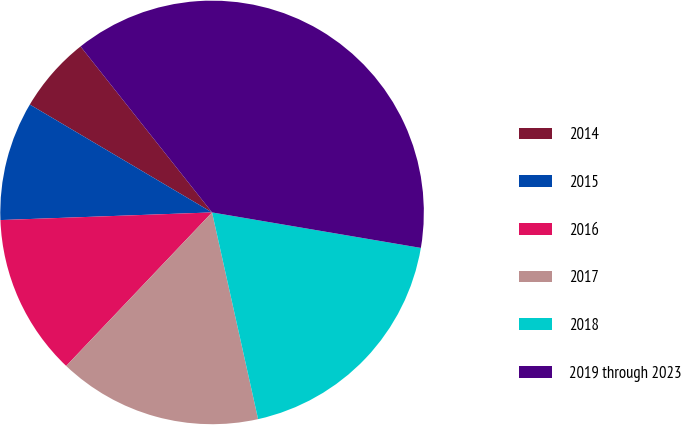Convert chart to OTSL. <chart><loc_0><loc_0><loc_500><loc_500><pie_chart><fcel>2014<fcel>2015<fcel>2016<fcel>2017<fcel>2018<fcel>2019 through 2023<nl><fcel>5.83%<fcel>9.08%<fcel>12.33%<fcel>15.58%<fcel>18.83%<fcel>38.34%<nl></chart> 